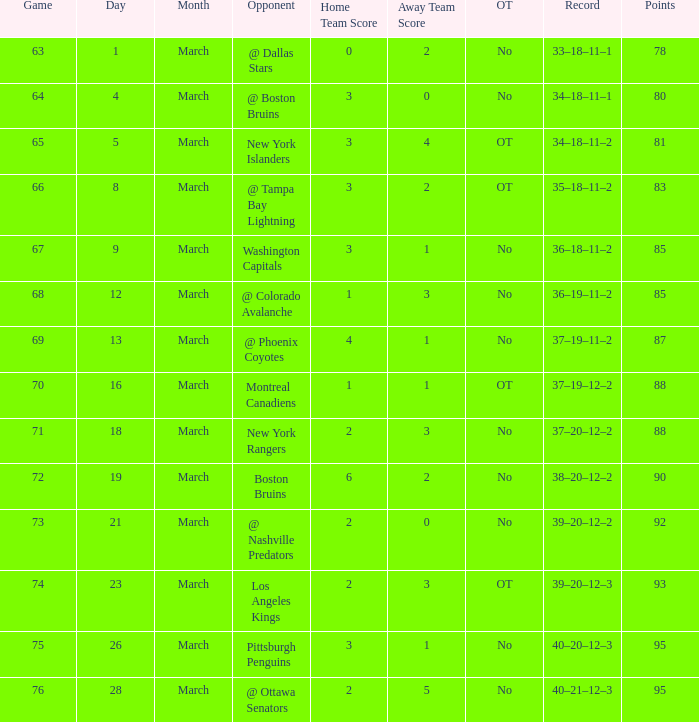Which Points have an Opponent of new york islanders, and a Game smaller than 65? None. 